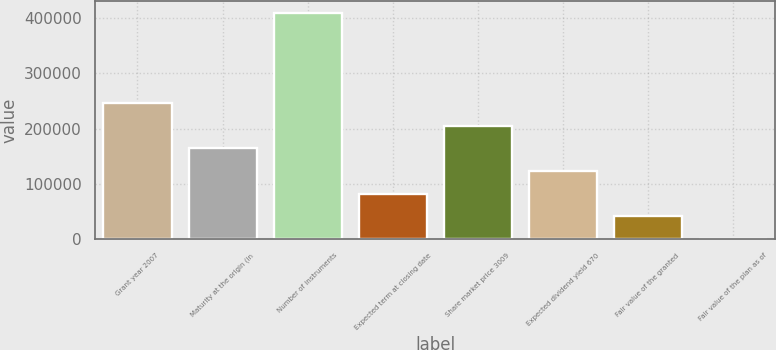Convert chart. <chart><loc_0><loc_0><loc_500><loc_500><bar_chart><fcel>Grant year 2007<fcel>Maturity at the origin (in<fcel>Number of instruments<fcel>Expected term at closing date<fcel>Share market price 3009<fcel>Expected dividend yield 670<fcel>Fair value of the granted<fcel>Fair value of the plan as of<nl><fcel>246240<fcel>164161<fcel>410400<fcel>82080.7<fcel>205200<fcel>123121<fcel>41040.8<fcel>0.9<nl></chart> 